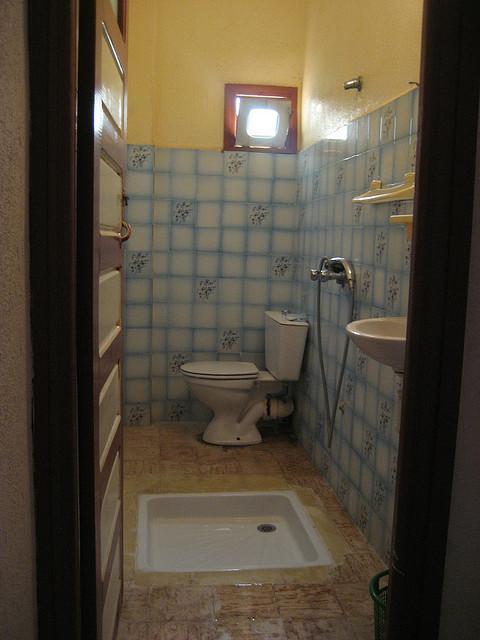How many white cars are on the road?
Give a very brief answer. 0. 